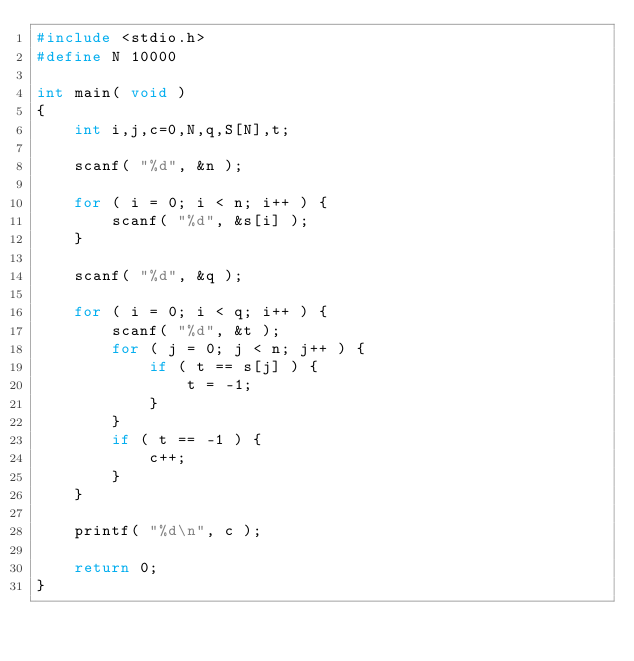Convert code to text. <code><loc_0><loc_0><loc_500><loc_500><_C_>#include <stdio.h>
#define N 10000

int main( void )
{
    int i,j,c=0,N,q,S[N],t;
    
    scanf( "%d", &n );
    
    for ( i = 0; i < n; i++ ) {
        scanf( "%d", &s[i] );
    }
    
    scanf( "%d", &q );
    
    for ( i = 0; i < q; i++ ) {
        scanf( "%d", &t );
        for ( j = 0; j < n; j++ ) {
            if ( t == s[j] ) {
                t = -1;
            }
        }
        if ( t == -1 ) {
            c++;
        }
    }
    
    printf( "%d\n", c );
    
    return 0;
}

</code> 